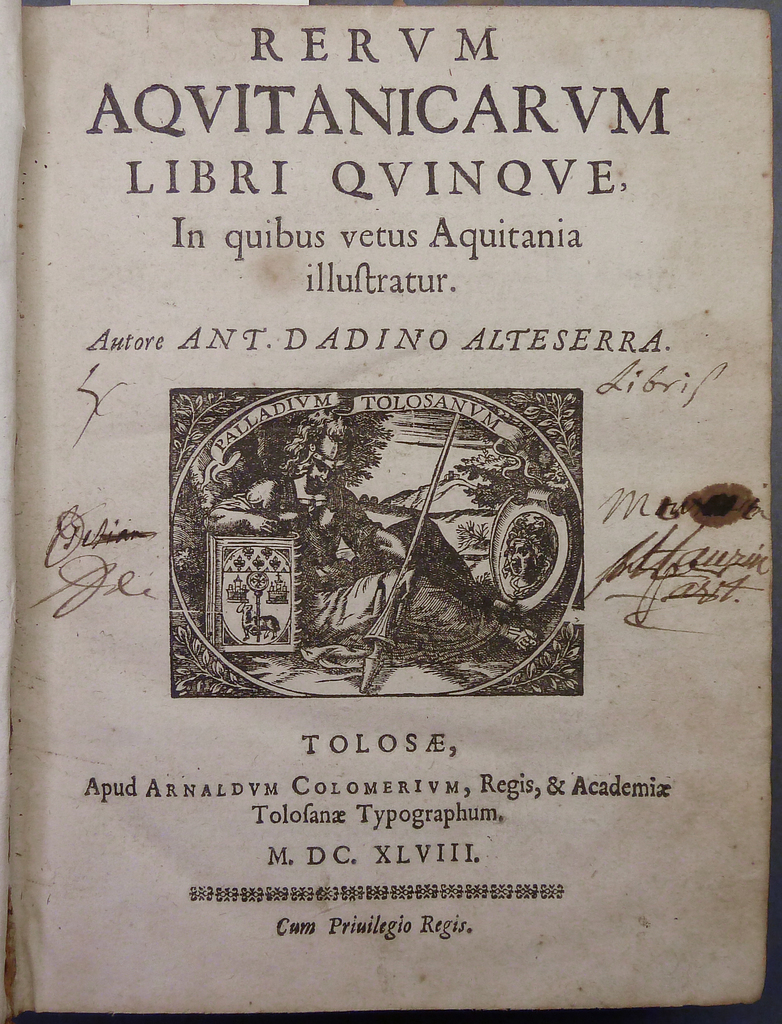Provide a one-sentence caption for the provided image. The image depicts a title page from the book 'RERVM AQVITANICARVM LIBRI QVINQVE,' an ancient text by ANT. DADINO ALTESERRA from 1648, exploring the history of old Aquitania, showcased with ornate decorations. 